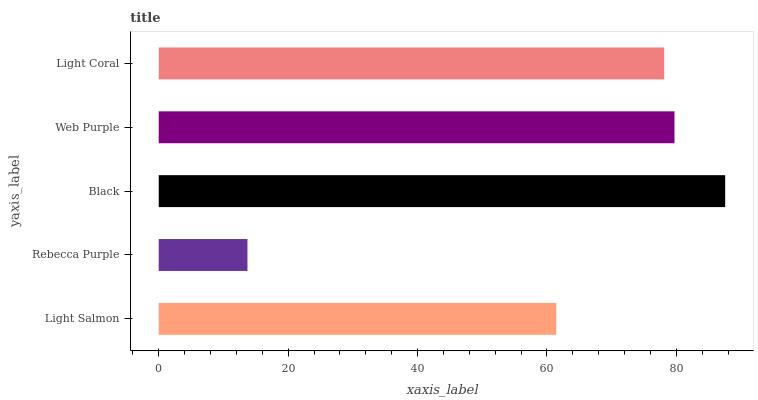Is Rebecca Purple the minimum?
Answer yes or no. Yes. Is Black the maximum?
Answer yes or no. Yes. Is Black the minimum?
Answer yes or no. No. Is Rebecca Purple the maximum?
Answer yes or no. No. Is Black greater than Rebecca Purple?
Answer yes or no. Yes. Is Rebecca Purple less than Black?
Answer yes or no. Yes. Is Rebecca Purple greater than Black?
Answer yes or no. No. Is Black less than Rebecca Purple?
Answer yes or no. No. Is Light Coral the high median?
Answer yes or no. Yes. Is Light Coral the low median?
Answer yes or no. Yes. Is Web Purple the high median?
Answer yes or no. No. Is Rebecca Purple the low median?
Answer yes or no. No. 